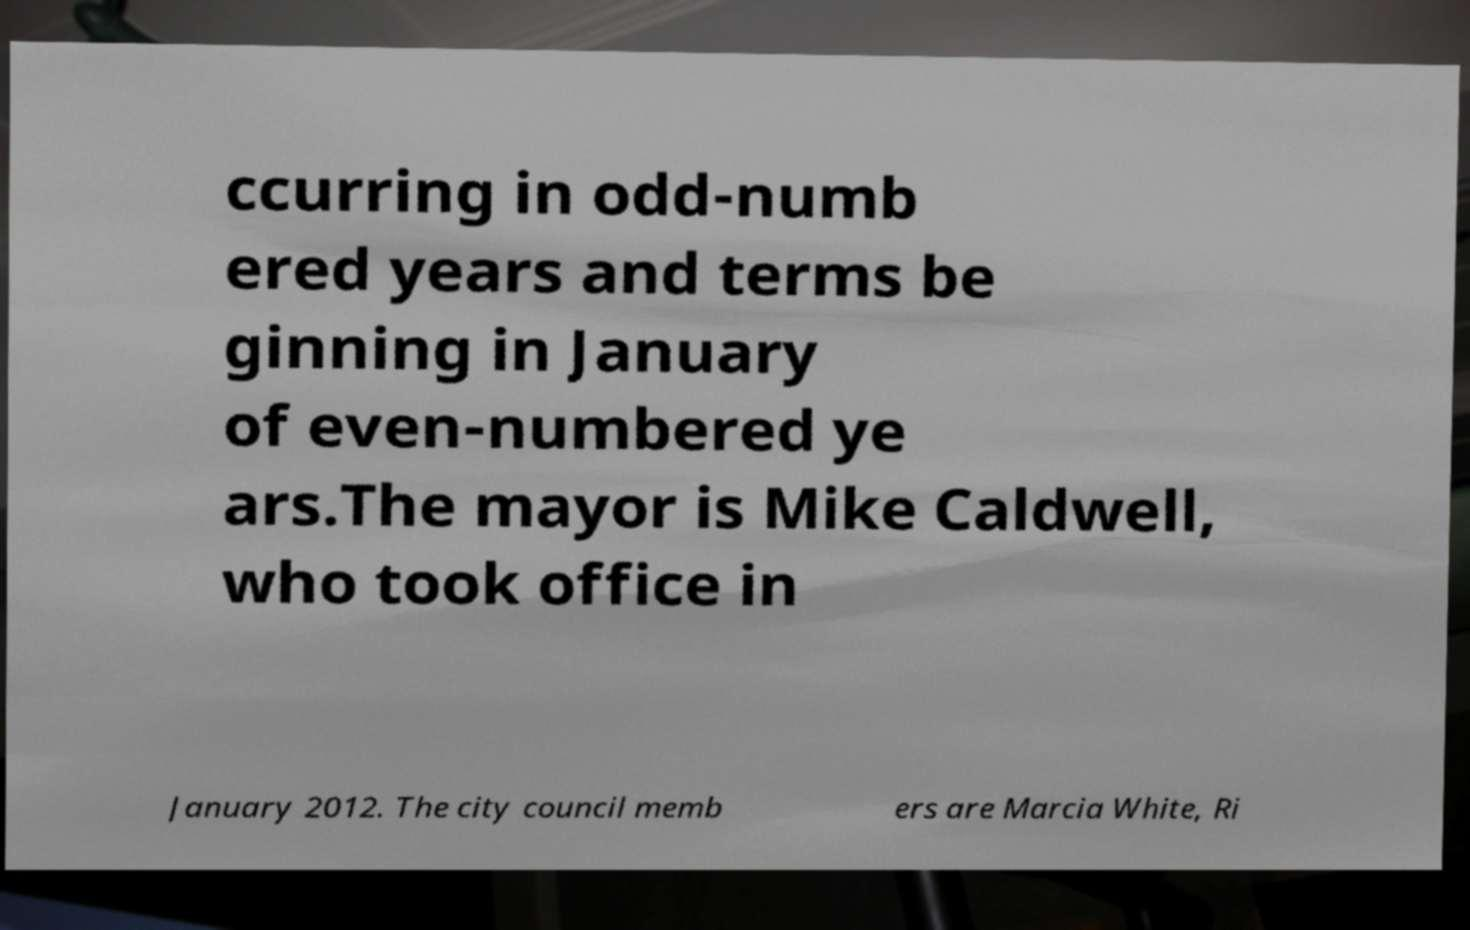Can you accurately transcribe the text from the provided image for me? ccurring in odd-numb ered years and terms be ginning in January of even-numbered ye ars.The mayor is Mike Caldwell, who took office in January 2012. The city council memb ers are Marcia White, Ri 